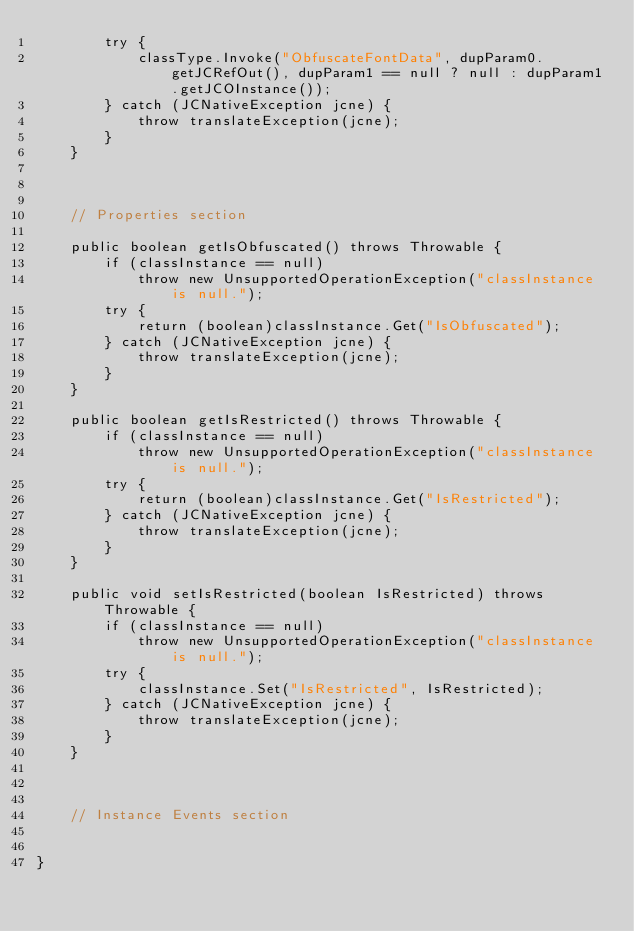<code> <loc_0><loc_0><loc_500><loc_500><_Java_>        try {
            classType.Invoke("ObfuscateFontData", dupParam0.getJCRefOut(), dupParam1 == null ? null : dupParam1.getJCOInstance());
        } catch (JCNativeException jcne) {
            throw translateException(jcne);
        }
    }


    
    // Properties section
    
    public boolean getIsObfuscated() throws Throwable {
        if (classInstance == null)
            throw new UnsupportedOperationException("classInstance is null.");
        try {
            return (boolean)classInstance.Get("IsObfuscated");
        } catch (JCNativeException jcne) {
            throw translateException(jcne);
        }
    }

    public boolean getIsRestricted() throws Throwable {
        if (classInstance == null)
            throw new UnsupportedOperationException("classInstance is null.");
        try {
            return (boolean)classInstance.Get("IsRestricted");
        } catch (JCNativeException jcne) {
            throw translateException(jcne);
        }
    }

    public void setIsRestricted(boolean IsRestricted) throws Throwable {
        if (classInstance == null)
            throw new UnsupportedOperationException("classInstance is null.");
        try {
            classInstance.Set("IsRestricted", IsRestricted);
        } catch (JCNativeException jcne) {
            throw translateException(jcne);
        }
    }



    // Instance Events section
    

}</code> 